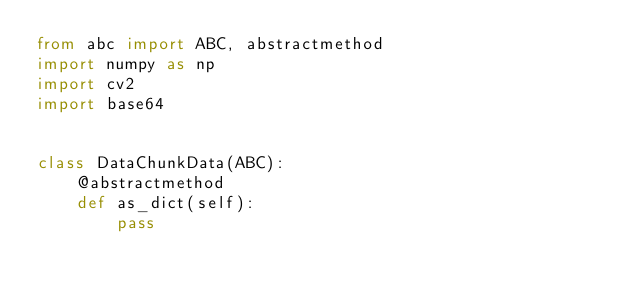<code> <loc_0><loc_0><loc_500><loc_500><_Python_>from abc import ABC, abstractmethod
import numpy as np
import cv2
import base64


class DataChunkData(ABC):
    @abstractmethod
    def as_dict(self):
        pass

</code> 